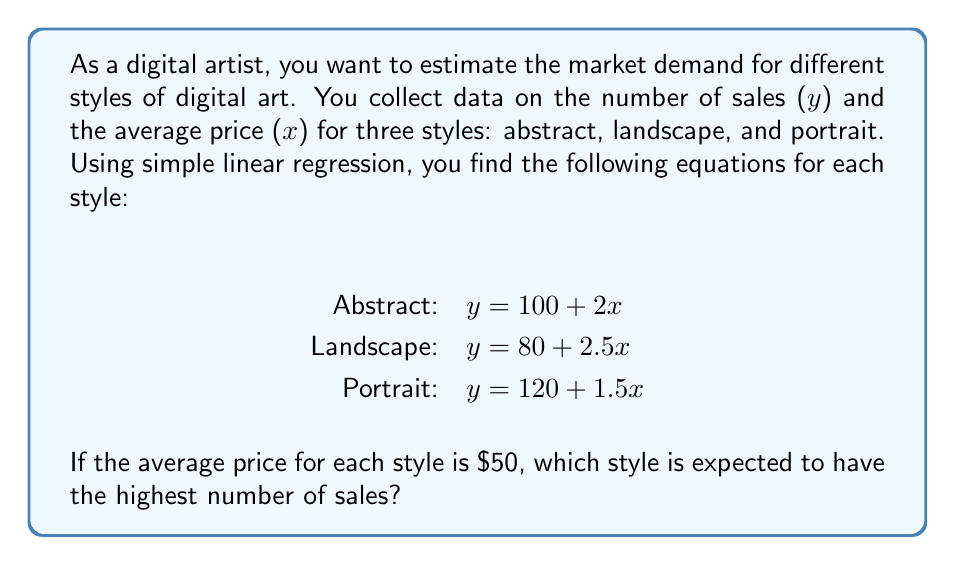Can you answer this question? To solve this problem, we need to follow these steps:

1. Identify the regression equation for each style:
   Abstract: $y = 100 + 2x$
   Landscape: $y = 80 + 2.5x$
   Portrait: $y = 120 + 1.5x$

2. Substitute the given average price ($x = 50$) into each equation:

   For Abstract:
   $y = 100 + 2(50)$
   $y = 100 + 100 = 200$

   For Landscape:
   $y = 80 + 2.5(50)$
   $y = 80 + 125 = 205$

   For Portrait:
   $y = 120 + 1.5(50)$
   $y = 120 + 75 = 195$

3. Compare the results:
   Abstract: 200 sales
   Landscape: 205 sales
   Portrait: 195 sales

4. Determine the style with the highest number of expected sales:
   Landscape has the highest number of expected sales at 205.
Answer: Landscape style 